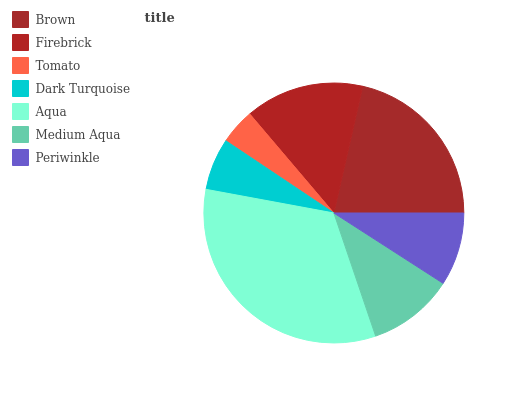Is Tomato the minimum?
Answer yes or no. Yes. Is Aqua the maximum?
Answer yes or no. Yes. Is Firebrick the minimum?
Answer yes or no. No. Is Firebrick the maximum?
Answer yes or no. No. Is Brown greater than Firebrick?
Answer yes or no. Yes. Is Firebrick less than Brown?
Answer yes or no. Yes. Is Firebrick greater than Brown?
Answer yes or no. No. Is Brown less than Firebrick?
Answer yes or no. No. Is Medium Aqua the high median?
Answer yes or no. Yes. Is Medium Aqua the low median?
Answer yes or no. Yes. Is Periwinkle the high median?
Answer yes or no. No. Is Aqua the low median?
Answer yes or no. No. 